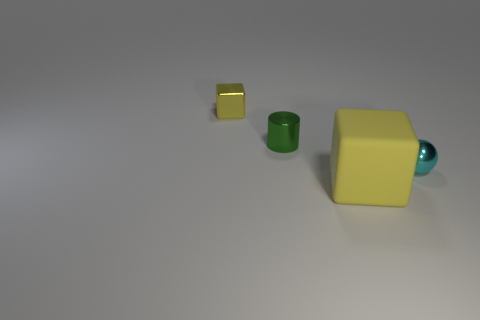Add 4 tiny green metallic cylinders. How many objects exist? 8 Subtract all cylinders. How many objects are left? 3 Subtract 1 spheres. How many spheres are left? 0 Subtract all brown cubes. Subtract all brown balls. How many cubes are left? 2 Subtract all blue matte things. Subtract all cubes. How many objects are left? 2 Add 4 balls. How many balls are left? 5 Add 4 blue metallic spheres. How many blue metallic spheres exist? 4 Subtract 0 cyan cylinders. How many objects are left? 4 